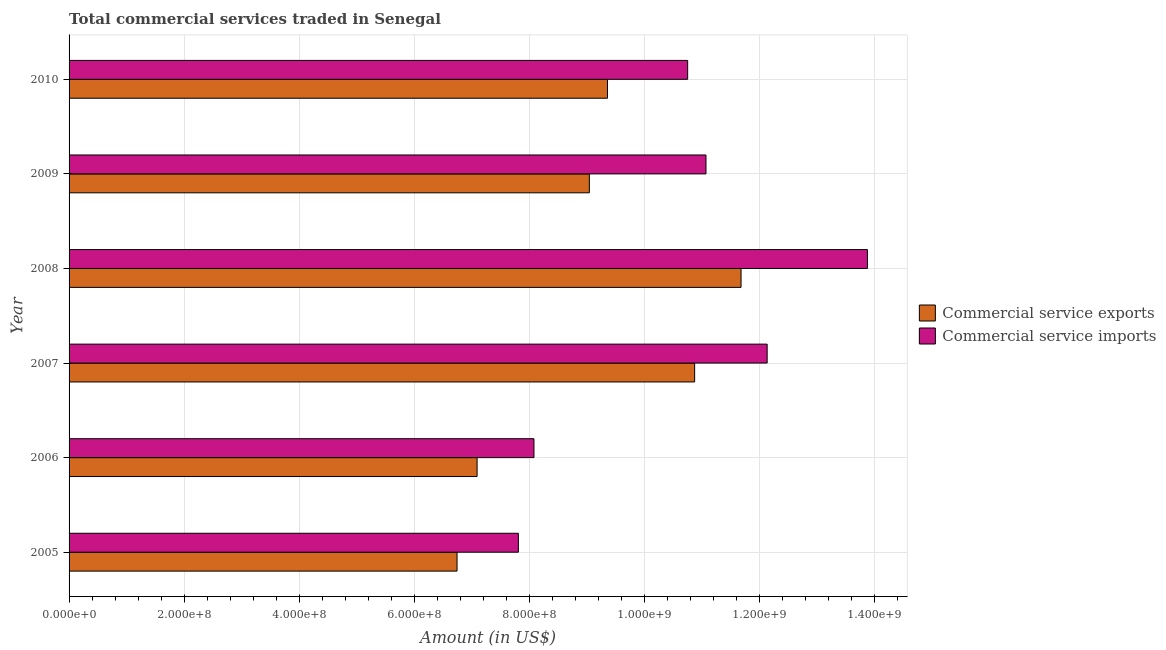How many different coloured bars are there?
Offer a terse response. 2. How many groups of bars are there?
Provide a short and direct response. 6. How many bars are there on the 5th tick from the top?
Your answer should be compact. 2. What is the label of the 6th group of bars from the top?
Provide a short and direct response. 2005. In how many cases, is the number of bars for a given year not equal to the number of legend labels?
Your answer should be compact. 0. What is the amount of commercial service imports in 2008?
Keep it short and to the point. 1.39e+09. Across all years, what is the maximum amount of commercial service exports?
Offer a very short reply. 1.17e+09. Across all years, what is the minimum amount of commercial service exports?
Provide a succinct answer. 6.75e+08. In which year was the amount of commercial service exports maximum?
Make the answer very short. 2008. What is the total amount of commercial service imports in the graph?
Your answer should be compact. 6.38e+09. What is the difference between the amount of commercial service exports in 2006 and that in 2008?
Offer a very short reply. -4.59e+08. What is the difference between the amount of commercial service imports in 2006 and the amount of commercial service exports in 2010?
Ensure brevity in your answer.  -1.28e+08. What is the average amount of commercial service imports per year?
Offer a very short reply. 1.06e+09. In the year 2005, what is the difference between the amount of commercial service imports and amount of commercial service exports?
Your answer should be very brief. 1.07e+08. In how many years, is the amount of commercial service imports greater than 360000000 US$?
Your answer should be compact. 6. What is the ratio of the amount of commercial service imports in 2006 to that in 2007?
Keep it short and to the point. 0.67. Is the difference between the amount of commercial service exports in 2007 and 2009 greater than the difference between the amount of commercial service imports in 2007 and 2009?
Give a very brief answer. Yes. What is the difference between the highest and the second highest amount of commercial service imports?
Offer a very short reply. 1.74e+08. What is the difference between the highest and the lowest amount of commercial service exports?
Ensure brevity in your answer.  4.94e+08. In how many years, is the amount of commercial service imports greater than the average amount of commercial service imports taken over all years?
Ensure brevity in your answer.  4. Is the sum of the amount of commercial service exports in 2007 and 2009 greater than the maximum amount of commercial service imports across all years?
Give a very brief answer. Yes. What does the 1st bar from the top in 2006 represents?
Keep it short and to the point. Commercial service imports. What does the 1st bar from the bottom in 2006 represents?
Make the answer very short. Commercial service exports. How many bars are there?
Keep it short and to the point. 12. Are all the bars in the graph horizontal?
Ensure brevity in your answer.  Yes. Does the graph contain any zero values?
Offer a very short reply. No. How are the legend labels stacked?
Offer a terse response. Vertical. What is the title of the graph?
Provide a short and direct response. Total commercial services traded in Senegal. What is the label or title of the Y-axis?
Your answer should be compact. Year. What is the Amount (in US$) in Commercial service exports in 2005?
Make the answer very short. 6.75e+08. What is the Amount (in US$) in Commercial service imports in 2005?
Make the answer very short. 7.81e+08. What is the Amount (in US$) of Commercial service exports in 2006?
Make the answer very short. 7.10e+08. What is the Amount (in US$) of Commercial service imports in 2006?
Your answer should be compact. 8.08e+08. What is the Amount (in US$) in Commercial service exports in 2007?
Provide a short and direct response. 1.09e+09. What is the Amount (in US$) in Commercial service imports in 2007?
Make the answer very short. 1.21e+09. What is the Amount (in US$) in Commercial service exports in 2008?
Offer a terse response. 1.17e+09. What is the Amount (in US$) in Commercial service imports in 2008?
Your answer should be compact. 1.39e+09. What is the Amount (in US$) of Commercial service exports in 2009?
Provide a short and direct response. 9.05e+08. What is the Amount (in US$) of Commercial service imports in 2009?
Offer a very short reply. 1.11e+09. What is the Amount (in US$) of Commercial service exports in 2010?
Offer a terse response. 9.36e+08. What is the Amount (in US$) of Commercial service imports in 2010?
Your response must be concise. 1.08e+09. Across all years, what is the maximum Amount (in US$) of Commercial service exports?
Your answer should be very brief. 1.17e+09. Across all years, what is the maximum Amount (in US$) of Commercial service imports?
Your answer should be very brief. 1.39e+09. Across all years, what is the minimum Amount (in US$) in Commercial service exports?
Make the answer very short. 6.75e+08. Across all years, what is the minimum Amount (in US$) in Commercial service imports?
Ensure brevity in your answer.  7.81e+08. What is the total Amount (in US$) in Commercial service exports in the graph?
Keep it short and to the point. 5.48e+09. What is the total Amount (in US$) of Commercial service imports in the graph?
Your answer should be compact. 6.38e+09. What is the difference between the Amount (in US$) of Commercial service exports in 2005 and that in 2006?
Your response must be concise. -3.49e+07. What is the difference between the Amount (in US$) of Commercial service imports in 2005 and that in 2006?
Your response must be concise. -2.71e+07. What is the difference between the Amount (in US$) of Commercial service exports in 2005 and that in 2007?
Make the answer very short. -4.13e+08. What is the difference between the Amount (in US$) in Commercial service imports in 2005 and that in 2007?
Provide a succinct answer. -4.33e+08. What is the difference between the Amount (in US$) in Commercial service exports in 2005 and that in 2008?
Your response must be concise. -4.94e+08. What is the difference between the Amount (in US$) of Commercial service imports in 2005 and that in 2008?
Keep it short and to the point. -6.07e+08. What is the difference between the Amount (in US$) in Commercial service exports in 2005 and that in 2009?
Your answer should be very brief. -2.30e+08. What is the difference between the Amount (in US$) in Commercial service imports in 2005 and that in 2009?
Offer a terse response. -3.26e+08. What is the difference between the Amount (in US$) of Commercial service exports in 2005 and that in 2010?
Your answer should be compact. -2.62e+08. What is the difference between the Amount (in US$) of Commercial service imports in 2005 and that in 2010?
Make the answer very short. -2.94e+08. What is the difference between the Amount (in US$) in Commercial service exports in 2006 and that in 2007?
Provide a short and direct response. -3.78e+08. What is the difference between the Amount (in US$) in Commercial service imports in 2006 and that in 2007?
Provide a succinct answer. -4.06e+08. What is the difference between the Amount (in US$) of Commercial service exports in 2006 and that in 2008?
Offer a terse response. -4.59e+08. What is the difference between the Amount (in US$) in Commercial service imports in 2006 and that in 2008?
Give a very brief answer. -5.80e+08. What is the difference between the Amount (in US$) in Commercial service exports in 2006 and that in 2009?
Provide a succinct answer. -1.95e+08. What is the difference between the Amount (in US$) of Commercial service imports in 2006 and that in 2009?
Give a very brief answer. -2.99e+08. What is the difference between the Amount (in US$) of Commercial service exports in 2006 and that in 2010?
Provide a succinct answer. -2.27e+08. What is the difference between the Amount (in US$) in Commercial service imports in 2006 and that in 2010?
Ensure brevity in your answer.  -2.67e+08. What is the difference between the Amount (in US$) of Commercial service exports in 2007 and that in 2008?
Give a very brief answer. -8.07e+07. What is the difference between the Amount (in US$) in Commercial service imports in 2007 and that in 2008?
Give a very brief answer. -1.74e+08. What is the difference between the Amount (in US$) in Commercial service exports in 2007 and that in 2009?
Ensure brevity in your answer.  1.83e+08. What is the difference between the Amount (in US$) of Commercial service imports in 2007 and that in 2009?
Offer a very short reply. 1.06e+08. What is the difference between the Amount (in US$) in Commercial service exports in 2007 and that in 2010?
Keep it short and to the point. 1.52e+08. What is the difference between the Amount (in US$) of Commercial service imports in 2007 and that in 2010?
Offer a very short reply. 1.38e+08. What is the difference between the Amount (in US$) of Commercial service exports in 2008 and that in 2009?
Offer a terse response. 2.64e+08. What is the difference between the Amount (in US$) in Commercial service imports in 2008 and that in 2009?
Offer a very short reply. 2.81e+08. What is the difference between the Amount (in US$) of Commercial service exports in 2008 and that in 2010?
Provide a succinct answer. 2.32e+08. What is the difference between the Amount (in US$) of Commercial service imports in 2008 and that in 2010?
Offer a very short reply. 3.13e+08. What is the difference between the Amount (in US$) in Commercial service exports in 2009 and that in 2010?
Your answer should be very brief. -3.16e+07. What is the difference between the Amount (in US$) of Commercial service imports in 2009 and that in 2010?
Provide a succinct answer. 3.19e+07. What is the difference between the Amount (in US$) of Commercial service exports in 2005 and the Amount (in US$) of Commercial service imports in 2006?
Your response must be concise. -1.34e+08. What is the difference between the Amount (in US$) of Commercial service exports in 2005 and the Amount (in US$) of Commercial service imports in 2007?
Offer a terse response. -5.39e+08. What is the difference between the Amount (in US$) of Commercial service exports in 2005 and the Amount (in US$) of Commercial service imports in 2008?
Provide a succinct answer. -7.14e+08. What is the difference between the Amount (in US$) in Commercial service exports in 2005 and the Amount (in US$) in Commercial service imports in 2009?
Offer a very short reply. -4.33e+08. What is the difference between the Amount (in US$) in Commercial service exports in 2005 and the Amount (in US$) in Commercial service imports in 2010?
Your answer should be very brief. -4.01e+08. What is the difference between the Amount (in US$) in Commercial service exports in 2006 and the Amount (in US$) in Commercial service imports in 2007?
Ensure brevity in your answer.  -5.04e+08. What is the difference between the Amount (in US$) of Commercial service exports in 2006 and the Amount (in US$) of Commercial service imports in 2008?
Make the answer very short. -6.79e+08. What is the difference between the Amount (in US$) of Commercial service exports in 2006 and the Amount (in US$) of Commercial service imports in 2009?
Give a very brief answer. -3.98e+08. What is the difference between the Amount (in US$) in Commercial service exports in 2006 and the Amount (in US$) in Commercial service imports in 2010?
Your answer should be very brief. -3.66e+08. What is the difference between the Amount (in US$) in Commercial service exports in 2007 and the Amount (in US$) in Commercial service imports in 2008?
Your answer should be very brief. -3.00e+08. What is the difference between the Amount (in US$) of Commercial service exports in 2007 and the Amount (in US$) of Commercial service imports in 2009?
Ensure brevity in your answer.  -1.97e+07. What is the difference between the Amount (in US$) in Commercial service exports in 2007 and the Amount (in US$) in Commercial service imports in 2010?
Offer a terse response. 1.21e+07. What is the difference between the Amount (in US$) in Commercial service exports in 2008 and the Amount (in US$) in Commercial service imports in 2009?
Keep it short and to the point. 6.10e+07. What is the difference between the Amount (in US$) in Commercial service exports in 2008 and the Amount (in US$) in Commercial service imports in 2010?
Your answer should be very brief. 9.28e+07. What is the difference between the Amount (in US$) in Commercial service exports in 2009 and the Amount (in US$) in Commercial service imports in 2010?
Provide a short and direct response. -1.71e+08. What is the average Amount (in US$) in Commercial service exports per year?
Offer a very short reply. 9.14e+08. What is the average Amount (in US$) in Commercial service imports per year?
Your response must be concise. 1.06e+09. In the year 2005, what is the difference between the Amount (in US$) of Commercial service exports and Amount (in US$) of Commercial service imports?
Give a very brief answer. -1.07e+08. In the year 2006, what is the difference between the Amount (in US$) of Commercial service exports and Amount (in US$) of Commercial service imports?
Keep it short and to the point. -9.89e+07. In the year 2007, what is the difference between the Amount (in US$) in Commercial service exports and Amount (in US$) in Commercial service imports?
Your answer should be very brief. -1.26e+08. In the year 2008, what is the difference between the Amount (in US$) of Commercial service exports and Amount (in US$) of Commercial service imports?
Offer a very short reply. -2.20e+08. In the year 2009, what is the difference between the Amount (in US$) of Commercial service exports and Amount (in US$) of Commercial service imports?
Give a very brief answer. -2.03e+08. In the year 2010, what is the difference between the Amount (in US$) of Commercial service exports and Amount (in US$) of Commercial service imports?
Give a very brief answer. -1.39e+08. What is the ratio of the Amount (in US$) in Commercial service exports in 2005 to that in 2006?
Your answer should be very brief. 0.95. What is the ratio of the Amount (in US$) of Commercial service imports in 2005 to that in 2006?
Offer a very short reply. 0.97. What is the ratio of the Amount (in US$) of Commercial service exports in 2005 to that in 2007?
Provide a succinct answer. 0.62. What is the ratio of the Amount (in US$) in Commercial service imports in 2005 to that in 2007?
Keep it short and to the point. 0.64. What is the ratio of the Amount (in US$) in Commercial service exports in 2005 to that in 2008?
Your response must be concise. 0.58. What is the ratio of the Amount (in US$) of Commercial service imports in 2005 to that in 2008?
Give a very brief answer. 0.56. What is the ratio of the Amount (in US$) of Commercial service exports in 2005 to that in 2009?
Provide a short and direct response. 0.75. What is the ratio of the Amount (in US$) in Commercial service imports in 2005 to that in 2009?
Ensure brevity in your answer.  0.71. What is the ratio of the Amount (in US$) in Commercial service exports in 2005 to that in 2010?
Keep it short and to the point. 0.72. What is the ratio of the Amount (in US$) of Commercial service imports in 2005 to that in 2010?
Offer a terse response. 0.73. What is the ratio of the Amount (in US$) of Commercial service exports in 2006 to that in 2007?
Give a very brief answer. 0.65. What is the ratio of the Amount (in US$) of Commercial service imports in 2006 to that in 2007?
Keep it short and to the point. 0.67. What is the ratio of the Amount (in US$) of Commercial service exports in 2006 to that in 2008?
Offer a very short reply. 0.61. What is the ratio of the Amount (in US$) in Commercial service imports in 2006 to that in 2008?
Offer a terse response. 0.58. What is the ratio of the Amount (in US$) of Commercial service exports in 2006 to that in 2009?
Ensure brevity in your answer.  0.78. What is the ratio of the Amount (in US$) of Commercial service imports in 2006 to that in 2009?
Keep it short and to the point. 0.73. What is the ratio of the Amount (in US$) in Commercial service exports in 2006 to that in 2010?
Keep it short and to the point. 0.76. What is the ratio of the Amount (in US$) in Commercial service imports in 2006 to that in 2010?
Ensure brevity in your answer.  0.75. What is the ratio of the Amount (in US$) in Commercial service exports in 2007 to that in 2008?
Provide a short and direct response. 0.93. What is the ratio of the Amount (in US$) of Commercial service imports in 2007 to that in 2008?
Give a very brief answer. 0.87. What is the ratio of the Amount (in US$) in Commercial service exports in 2007 to that in 2009?
Your answer should be compact. 1.2. What is the ratio of the Amount (in US$) of Commercial service imports in 2007 to that in 2009?
Your answer should be very brief. 1.1. What is the ratio of the Amount (in US$) in Commercial service exports in 2007 to that in 2010?
Ensure brevity in your answer.  1.16. What is the ratio of the Amount (in US$) of Commercial service imports in 2007 to that in 2010?
Make the answer very short. 1.13. What is the ratio of the Amount (in US$) of Commercial service exports in 2008 to that in 2009?
Keep it short and to the point. 1.29. What is the ratio of the Amount (in US$) in Commercial service imports in 2008 to that in 2009?
Make the answer very short. 1.25. What is the ratio of the Amount (in US$) of Commercial service exports in 2008 to that in 2010?
Keep it short and to the point. 1.25. What is the ratio of the Amount (in US$) in Commercial service imports in 2008 to that in 2010?
Make the answer very short. 1.29. What is the ratio of the Amount (in US$) in Commercial service exports in 2009 to that in 2010?
Your answer should be compact. 0.97. What is the ratio of the Amount (in US$) in Commercial service imports in 2009 to that in 2010?
Offer a terse response. 1.03. What is the difference between the highest and the second highest Amount (in US$) in Commercial service exports?
Offer a very short reply. 8.07e+07. What is the difference between the highest and the second highest Amount (in US$) of Commercial service imports?
Give a very brief answer. 1.74e+08. What is the difference between the highest and the lowest Amount (in US$) of Commercial service exports?
Offer a very short reply. 4.94e+08. What is the difference between the highest and the lowest Amount (in US$) in Commercial service imports?
Offer a terse response. 6.07e+08. 